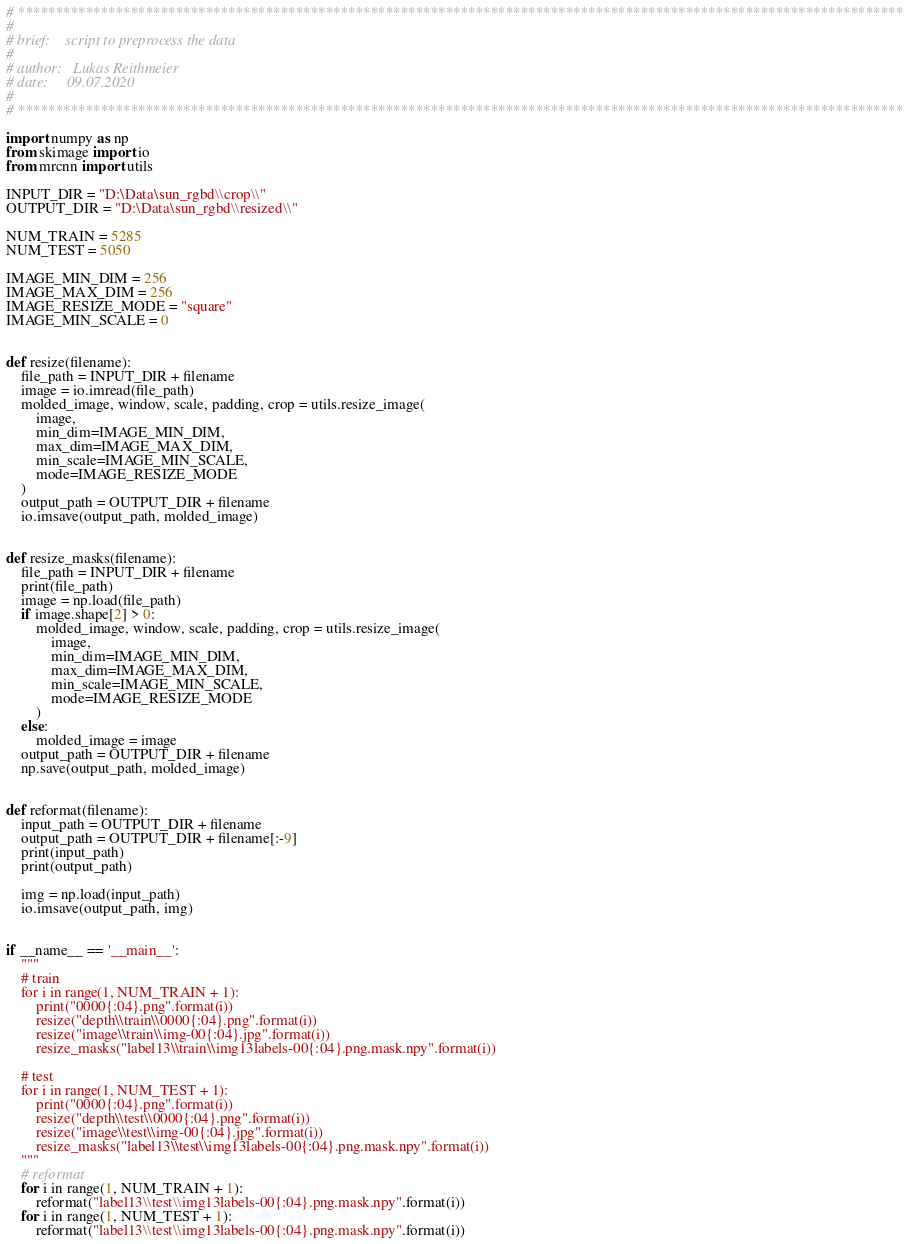Convert code to text. <code><loc_0><loc_0><loc_500><loc_500><_Python_># **********************************************************************************************************************
#
# brief:    script to preprocess the data
#
# author:   Lukas Reithmeier
# date:     09.07.2020
#
# **********************************************************************************************************************

import numpy as np
from skimage import io
from mrcnn import utils

INPUT_DIR = "D:\Data\sun_rgbd\\crop\\"
OUTPUT_DIR = "D:\Data\sun_rgbd\\resized\\"

NUM_TRAIN = 5285
NUM_TEST = 5050

IMAGE_MIN_DIM = 256
IMAGE_MAX_DIM = 256
IMAGE_RESIZE_MODE = "square"
IMAGE_MIN_SCALE = 0


def resize(filename):
    file_path = INPUT_DIR + filename
    image = io.imread(file_path)
    molded_image, window, scale, padding, crop = utils.resize_image(
        image,
        min_dim=IMAGE_MIN_DIM,
        max_dim=IMAGE_MAX_DIM,
        min_scale=IMAGE_MIN_SCALE,
        mode=IMAGE_RESIZE_MODE
    )
    output_path = OUTPUT_DIR + filename
    io.imsave(output_path, molded_image)


def resize_masks(filename):
    file_path = INPUT_DIR + filename
    print(file_path)
    image = np.load(file_path)
    if image.shape[2] > 0:
        molded_image, window, scale, padding, crop = utils.resize_image(
            image,
            min_dim=IMAGE_MIN_DIM,
            max_dim=IMAGE_MAX_DIM,
            min_scale=IMAGE_MIN_SCALE,
            mode=IMAGE_RESIZE_MODE
        )
    else:
        molded_image = image
    output_path = OUTPUT_DIR + filename
    np.save(output_path, molded_image)


def reformat(filename):
    input_path = OUTPUT_DIR + filename
    output_path = OUTPUT_DIR + filename[:-9]
    print(input_path)
    print(output_path)

    img = np.load(input_path)
    io.imsave(output_path, img)


if __name__ == '__main__':
    """
    # train
    for i in range(1, NUM_TRAIN + 1):
        print("0000{:04}.png".format(i))
        resize("depth\\train\\0000{:04}.png".format(i))
        resize("image\\train\\img-00{:04}.jpg".format(i))
        resize_masks("label13\\train\\img13labels-00{:04}.png.mask.npy".format(i))

    # test
    for i in range(1, NUM_TEST + 1):
        print("0000{:04}.png".format(i))
        resize("depth\\test\\0000{:04}.png".format(i))
        resize("image\\test\\img-00{:04}.jpg".format(i))
        resize_masks("label13\\test\\img13labels-00{:04}.png.mask.npy".format(i))
    """
    # reformat
    for i in range(1, NUM_TRAIN + 1):
        reformat("label13\\test\\img13labels-00{:04}.png.mask.npy".format(i))
    for i in range(1, NUM_TEST + 1):
        reformat("label13\\test\\img13labels-00{:04}.png.mask.npy".format(i))
</code> 